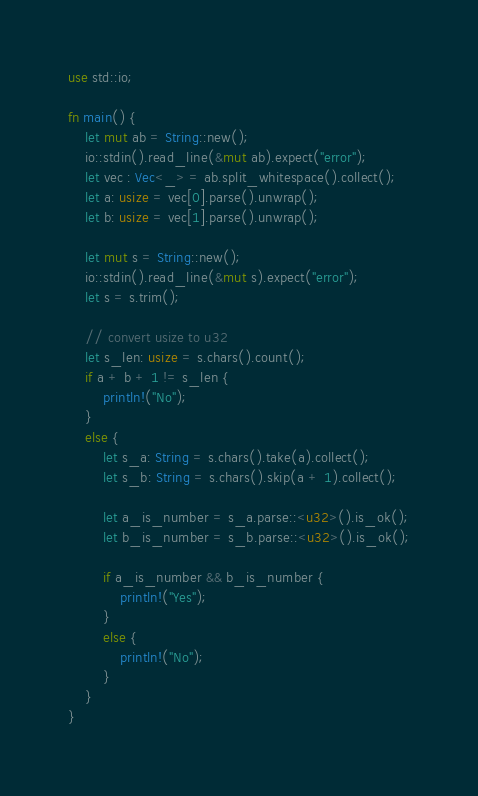<code> <loc_0><loc_0><loc_500><loc_500><_Rust_>use std::io;

fn main() {
    let mut ab = String::new();
    io::stdin().read_line(&mut ab).expect("error");
    let vec : Vec<_> = ab.split_whitespace().collect();
    let a: usize = vec[0].parse().unwrap();
    let b: usize = vec[1].parse().unwrap();

    let mut s = String::new();
    io::stdin().read_line(&mut s).expect("error");
    let s = s.trim();

    // convert usize to u32
    let s_len: usize = s.chars().count();
    if a + b + 1 != s_len {
        println!("No");
    }
    else {
        let s_a: String = s.chars().take(a).collect();
        let s_b: String = s.chars().skip(a + 1).collect();

        let a_is_number = s_a.parse::<u32>().is_ok();
        let b_is_number = s_b.parse::<u32>().is_ok();

        if a_is_number && b_is_number {
            println!("Yes");
        }
        else {
            println!("No");
        }
    }
}
</code> 